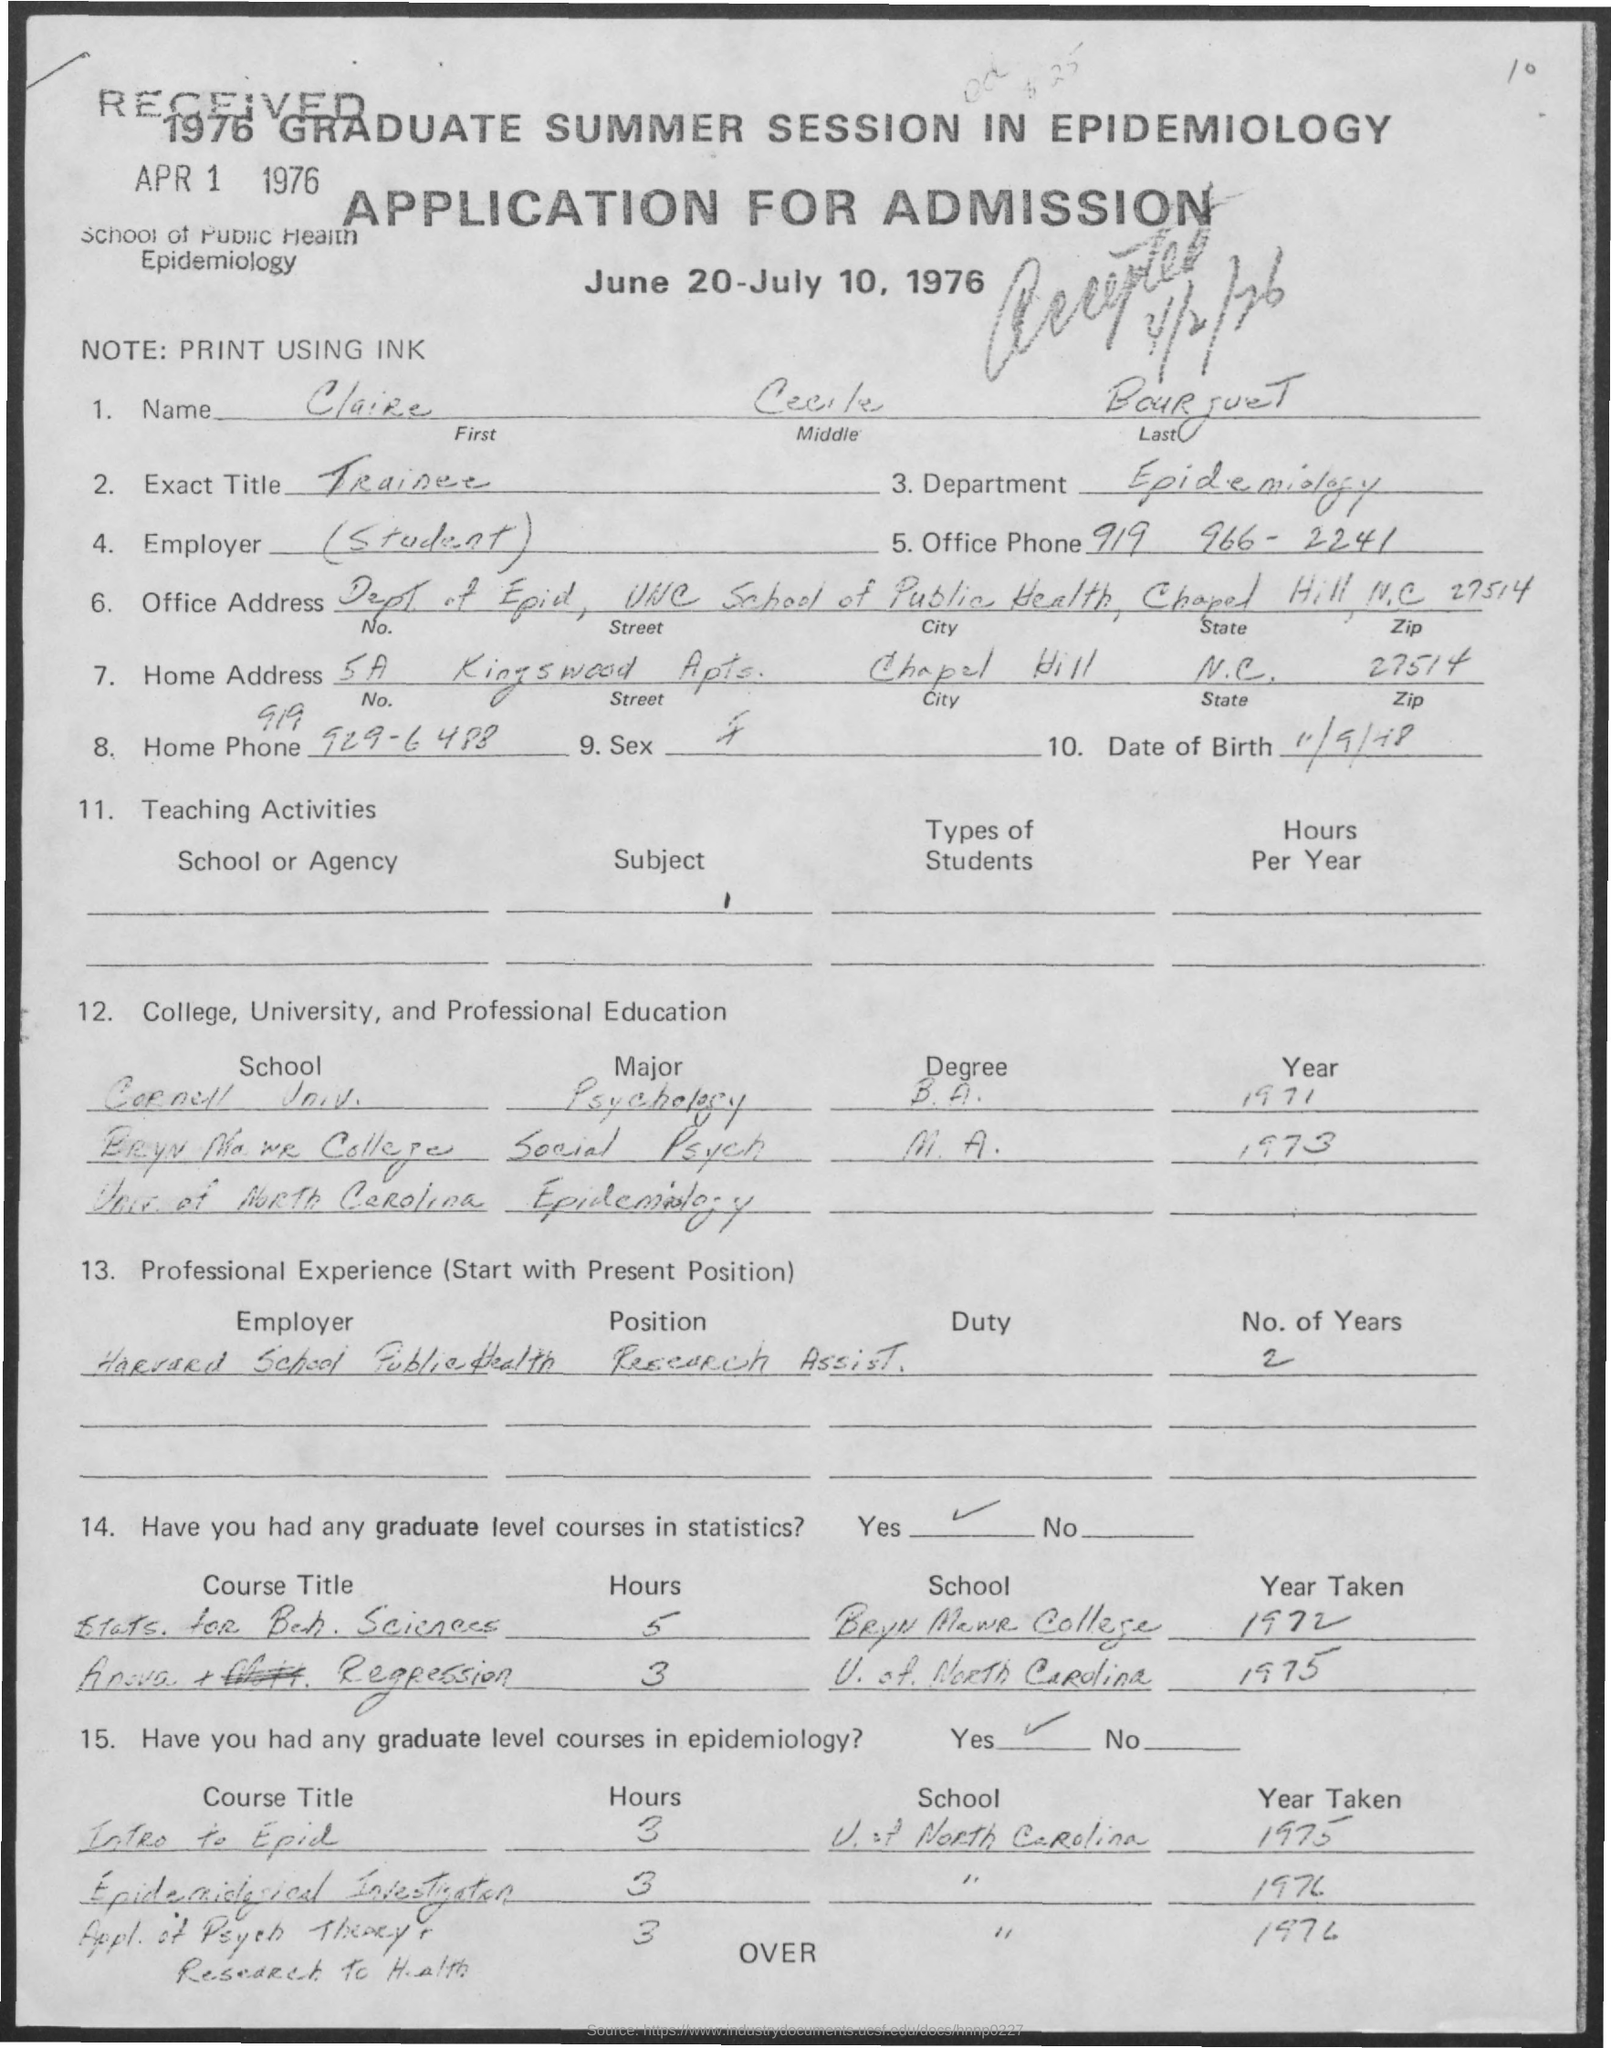What is the Title of the document?
Your response must be concise. APPLICATION FOR ADMISSION. What is the First Name?
Offer a very short reply. Claire. What is the Last Name?
Provide a succinct answer. BOURJUET. What is the Exact Title?
Make the answer very short. TRAINEE. What is the Department?
Offer a terse response. Epidemiology. What is the Office Phone?
Your answer should be compact. 919 966-2241. 